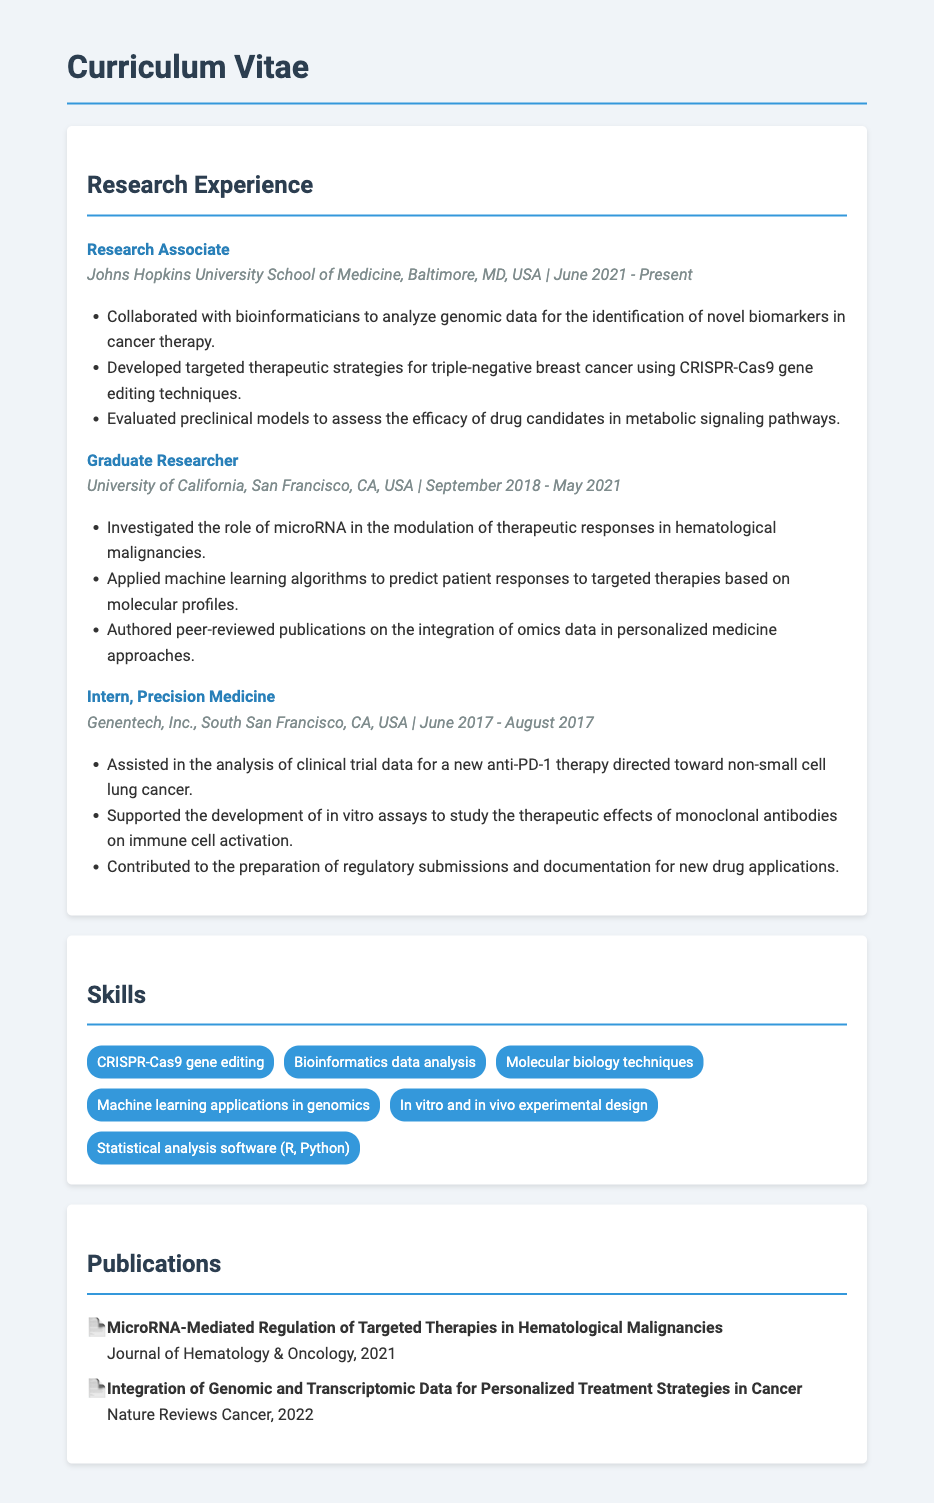What is the current position held by the biochemist? The document states that the current position is "Research Associate."
Answer: Research Associate At which university did the biochemist conduct their graduate research? The document mentions the University of California, San Francisco for graduate research.
Answer: University of California, San Francisco What specific disease is targeted in the current therapeutic strategies mentioned? The document specifies "triple-negative breast cancer" as the targeted disease.
Answer: triple-negative breast cancer In what year did the biochemist start their current position? The document indicates that the current position started in June 2021.
Answer: June 2021 Which gene editing technique is mentioned in the current position? The document refers to "CRISPR-Cas9 gene editing techniques" in the current position description.
Answer: CRISPR-Cas9 What role did the biochemist have at Genentech, Inc.? The document identifies the role as "Intern, Precision Medicine."
Answer: Intern, Precision Medicine How many peer-reviewed publications are listed in the document? The document provides information about two peer-reviewed publications authored by the biochemist.
Answer: 2 What application is used to predict patient responses to targeted therapies? The document states that "machine learning algorithms" are used for predictions.
Answer: machine learning algorithms Which journal published the article on microRNA? The document names the "Journal of Hematology & Oncology" as the publication for the microRNA article.
Answer: Journal of Hematology & Oncology 